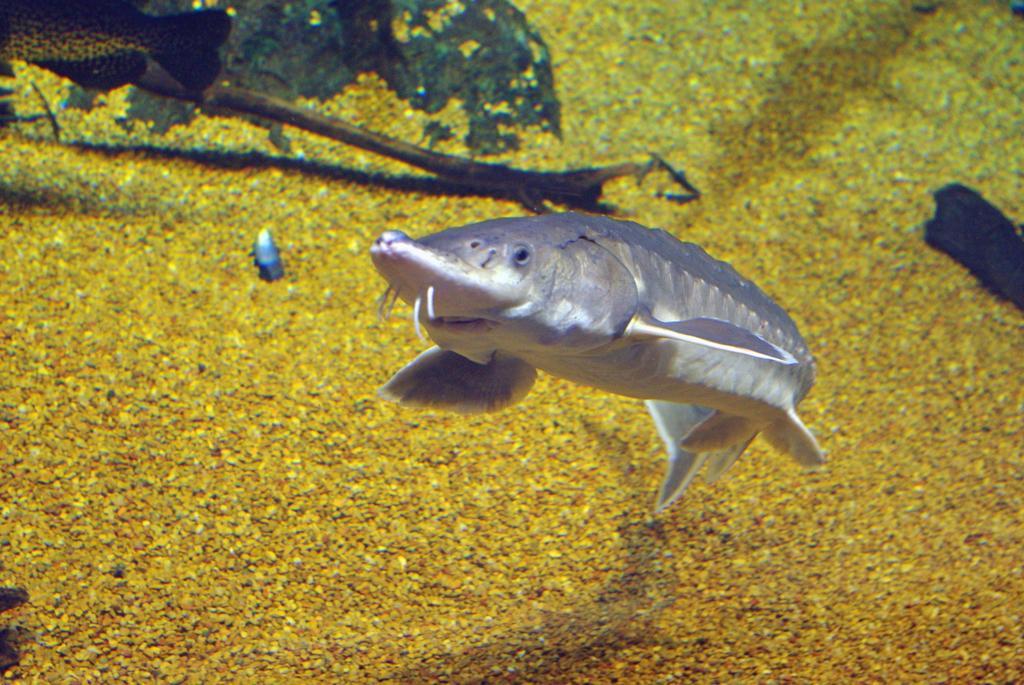Could you give a brief overview of what you see in this image? In this picture we can see a fish. In the top left corner we can see partial part of a fish. 